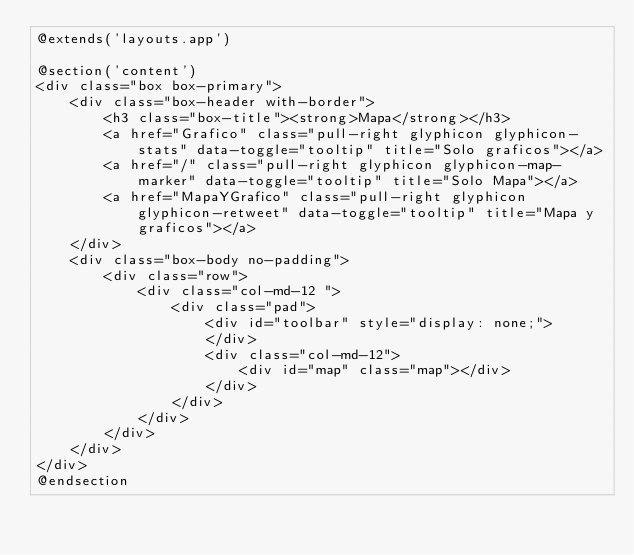Convert code to text. <code><loc_0><loc_0><loc_500><loc_500><_PHP_>@extends('layouts.app')

@section('content')
<div class="box box-primary">
    <div class="box-header with-border">
        <h3 class="box-title"><strong>Mapa</strong></h3>
        <a href="Grafico" class="pull-right glyphicon glyphicon-stats" data-toggle="tooltip" title="Solo graficos"></a>
        <a href="/" class="pull-right glyphicon glyphicon-map-marker" data-toggle="tooltip" title="Solo Mapa"></a>
        <a href="MapaYGrafico" class="pull-right glyphicon glyphicon-retweet" data-toggle="tooltip" title="Mapa y graficos"></a>
    </div>
    <div class="box-body no-padding">
        <div class="row">
            <div class="col-md-12 ">
                <div class="pad">
                    <div id="toolbar" style="display: none;">
                    </div>
                    <div class="col-md-12">
                        <div id="map" class="map"></div>                                        
                    </div>
                </div>
            </div>
        </div>                            
    </div>
</div>
@endsection</code> 